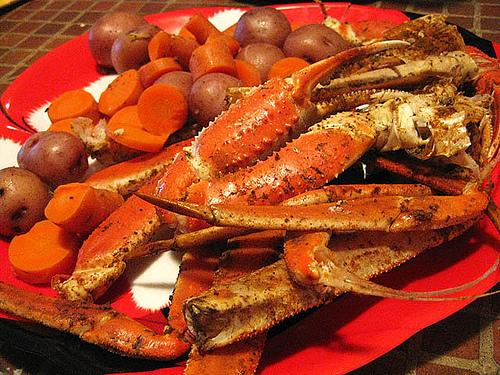What type of seafood is situated on the plate?
Quick response, please. Lobster. Does this meal look cooked?
Quick response, please. Yes. What kind of food is this?
Write a very short answer. Lobster. 